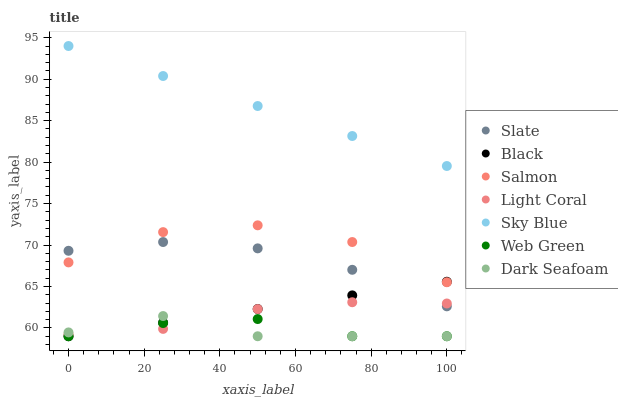Does Dark Seafoam have the minimum area under the curve?
Answer yes or no. Yes. Does Sky Blue have the maximum area under the curve?
Answer yes or no. Yes. Does Salmon have the minimum area under the curve?
Answer yes or no. No. Does Salmon have the maximum area under the curve?
Answer yes or no. No. Is Black the smoothest?
Answer yes or no. Yes. Is Salmon the roughest?
Answer yes or no. Yes. Is Web Green the smoothest?
Answer yes or no. No. Is Web Green the roughest?
Answer yes or no. No. Does Web Green have the lowest value?
Answer yes or no. Yes. Does Salmon have the lowest value?
Answer yes or no. No. Does Sky Blue have the highest value?
Answer yes or no. Yes. Does Salmon have the highest value?
Answer yes or no. No. Is Dark Seafoam less than Salmon?
Answer yes or no. Yes. Is Salmon greater than Web Green?
Answer yes or no. Yes. Does Slate intersect Salmon?
Answer yes or no. Yes. Is Slate less than Salmon?
Answer yes or no. No. Is Slate greater than Salmon?
Answer yes or no. No. Does Dark Seafoam intersect Salmon?
Answer yes or no. No. 